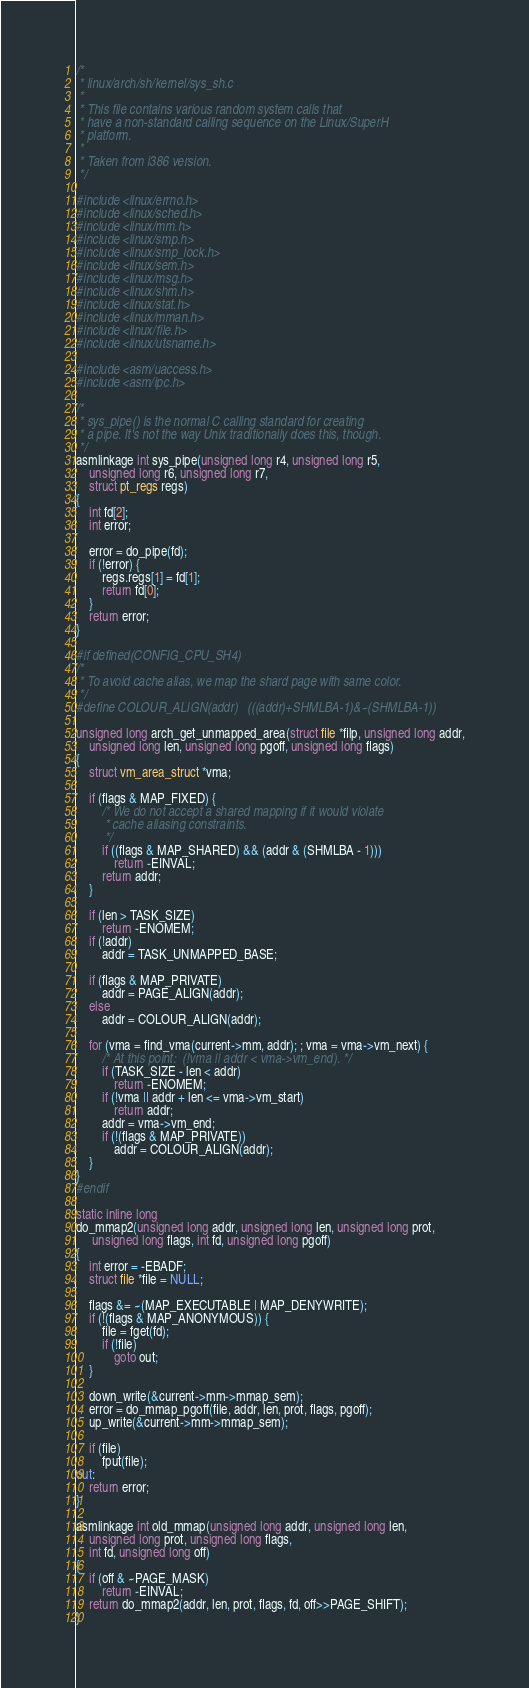Convert code to text. <code><loc_0><loc_0><loc_500><loc_500><_C_>/*
 * linux/arch/sh/kernel/sys_sh.c
 *
 * This file contains various random system calls that
 * have a non-standard calling sequence on the Linux/SuperH
 * platform.
 *
 * Taken from i386 version.
 */

#include <linux/errno.h>
#include <linux/sched.h>
#include <linux/mm.h>
#include <linux/smp.h>
#include <linux/smp_lock.h>
#include <linux/sem.h>
#include <linux/msg.h>
#include <linux/shm.h>
#include <linux/stat.h>
#include <linux/mman.h>
#include <linux/file.h>
#include <linux/utsname.h>

#include <asm/uaccess.h>
#include <asm/ipc.h>

/*
 * sys_pipe() is the normal C calling standard for creating
 * a pipe. It's not the way Unix traditionally does this, though.
 */
asmlinkage int sys_pipe(unsigned long r4, unsigned long r5,
	unsigned long r6, unsigned long r7,
	struct pt_regs regs)
{
	int fd[2];
	int error;

	error = do_pipe(fd);
	if (!error) {
		regs.regs[1] = fd[1];
		return fd[0];
	}
	return error;
}

#if defined(CONFIG_CPU_SH4)
/*
 * To avoid cache alias, we map the shard page with same color.
 */
#define COLOUR_ALIGN(addr)	(((addr)+SHMLBA-1)&~(SHMLBA-1))

unsigned long arch_get_unmapped_area(struct file *filp, unsigned long addr,
	unsigned long len, unsigned long pgoff, unsigned long flags)
{
	struct vm_area_struct *vma;

	if (flags & MAP_FIXED) {
		/* We do not accept a shared mapping if it would violate
		 * cache aliasing constraints.
		 */
		if ((flags & MAP_SHARED) && (addr & (SHMLBA - 1)))
			return -EINVAL;
		return addr;
	}

	if (len > TASK_SIZE)
		return -ENOMEM;
	if (!addr)
		addr = TASK_UNMAPPED_BASE;

	if (flags & MAP_PRIVATE)
		addr = PAGE_ALIGN(addr);
	else
		addr = COLOUR_ALIGN(addr);

	for (vma = find_vma(current->mm, addr); ; vma = vma->vm_next) {
		/* At this point:  (!vma || addr < vma->vm_end). */
		if (TASK_SIZE - len < addr)
			return -ENOMEM;
		if (!vma || addr + len <= vma->vm_start)
			return addr;
		addr = vma->vm_end;
		if (!(flags & MAP_PRIVATE))
			addr = COLOUR_ALIGN(addr);
	}
}
#endif

static inline long
do_mmap2(unsigned long addr, unsigned long len, unsigned long prot, 
	 unsigned long flags, int fd, unsigned long pgoff)
{
	int error = -EBADF;
	struct file *file = NULL;

	flags &= ~(MAP_EXECUTABLE | MAP_DENYWRITE);
	if (!(flags & MAP_ANONYMOUS)) {
		file = fget(fd);
		if (!file)
			goto out;
	}

	down_write(&current->mm->mmap_sem);
	error = do_mmap_pgoff(file, addr, len, prot, flags, pgoff);
	up_write(&current->mm->mmap_sem);

	if (file)
		fput(file);
out:
	return error;
}

asmlinkage int old_mmap(unsigned long addr, unsigned long len,
	unsigned long prot, unsigned long flags,
	int fd, unsigned long off)
{
	if (off & ~PAGE_MASK)
		return -EINVAL;
	return do_mmap2(addr, len, prot, flags, fd, off>>PAGE_SHIFT);
}
</code> 